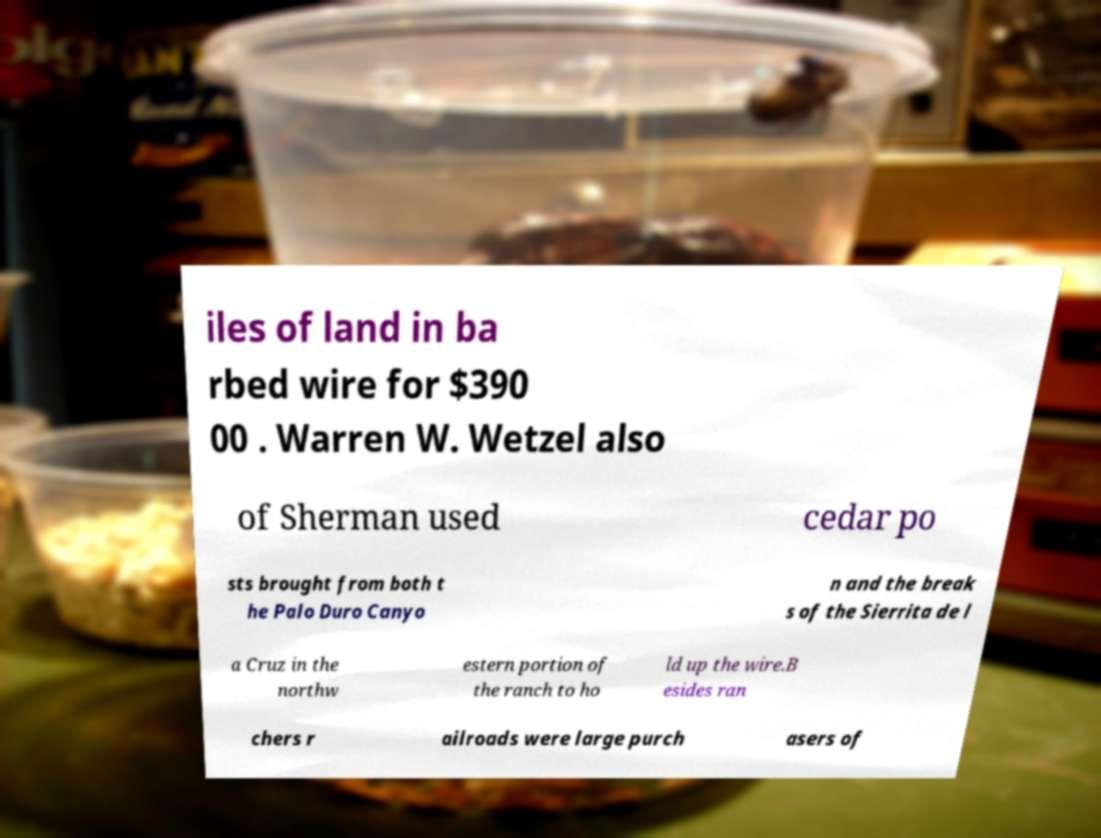For documentation purposes, I need the text within this image transcribed. Could you provide that? iles of land in ba rbed wire for $390 00 . Warren W. Wetzel also of Sherman used cedar po sts brought from both t he Palo Duro Canyo n and the break s of the Sierrita de l a Cruz in the northw estern portion of the ranch to ho ld up the wire.B esides ran chers r ailroads were large purch asers of 